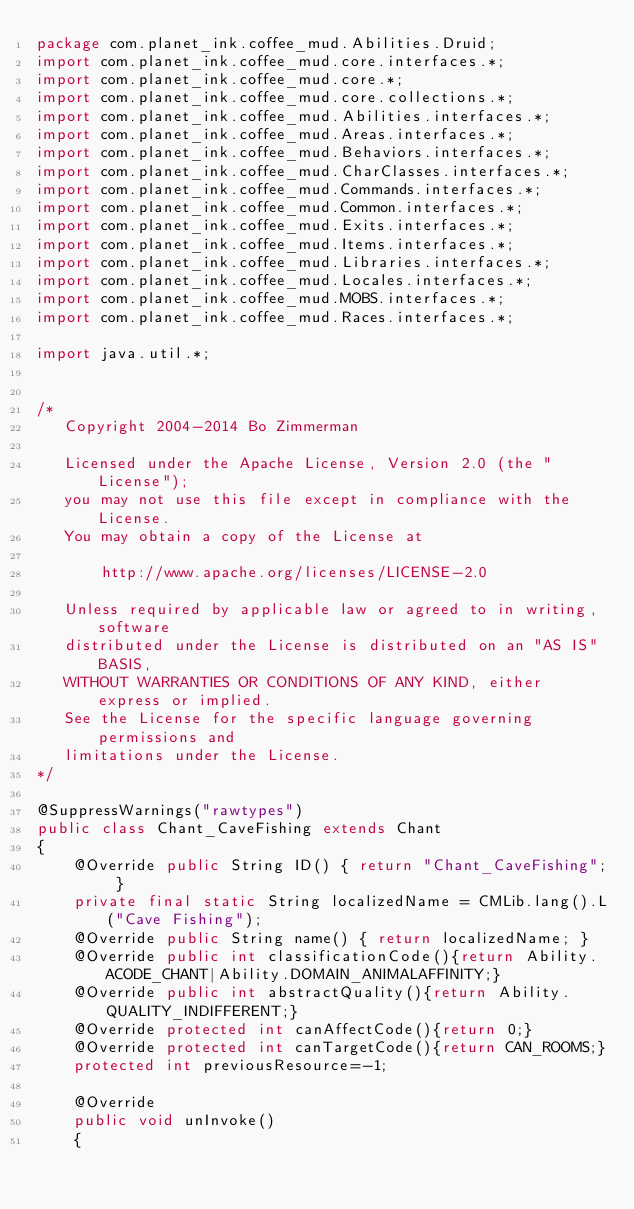<code> <loc_0><loc_0><loc_500><loc_500><_Java_>package com.planet_ink.coffee_mud.Abilities.Druid;
import com.planet_ink.coffee_mud.core.interfaces.*;
import com.planet_ink.coffee_mud.core.*;
import com.planet_ink.coffee_mud.core.collections.*;
import com.planet_ink.coffee_mud.Abilities.interfaces.*;
import com.planet_ink.coffee_mud.Areas.interfaces.*;
import com.planet_ink.coffee_mud.Behaviors.interfaces.*;
import com.planet_ink.coffee_mud.CharClasses.interfaces.*;
import com.planet_ink.coffee_mud.Commands.interfaces.*;
import com.planet_ink.coffee_mud.Common.interfaces.*;
import com.planet_ink.coffee_mud.Exits.interfaces.*;
import com.planet_ink.coffee_mud.Items.interfaces.*;
import com.planet_ink.coffee_mud.Libraries.interfaces.*;
import com.planet_ink.coffee_mud.Locales.interfaces.*;
import com.planet_ink.coffee_mud.MOBS.interfaces.*;
import com.planet_ink.coffee_mud.Races.interfaces.*;

import java.util.*;


/*
   Copyright 2004-2014 Bo Zimmerman

   Licensed under the Apache License, Version 2.0 (the "License");
   you may not use this file except in compliance with the License.
   You may obtain a copy of the License at

	   http://www.apache.org/licenses/LICENSE-2.0

   Unless required by applicable law or agreed to in writing, software
   distributed under the License is distributed on an "AS IS" BASIS,
   WITHOUT WARRANTIES OR CONDITIONS OF ANY KIND, either express or implied.
   See the License for the specific language governing permissions and
   limitations under the License.
*/

@SuppressWarnings("rawtypes")
public class Chant_CaveFishing extends Chant
{
	@Override public String ID() { return "Chant_CaveFishing"; }
	private final static String localizedName = CMLib.lang().L("Cave Fishing");
	@Override public String name() { return localizedName; }
	@Override public int classificationCode(){return Ability.ACODE_CHANT|Ability.DOMAIN_ANIMALAFFINITY;}
	@Override public int abstractQuality(){return Ability.QUALITY_INDIFFERENT;}
	@Override protected int canAffectCode(){return 0;}
	@Override protected int canTargetCode(){return CAN_ROOMS;}
	protected int previousResource=-1;

	@Override
	public void unInvoke()
	{</code> 